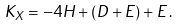Convert formula to latex. <formula><loc_0><loc_0><loc_500><loc_500>K _ { X } = - 4 H + ( D + E ) + E \, .</formula> 